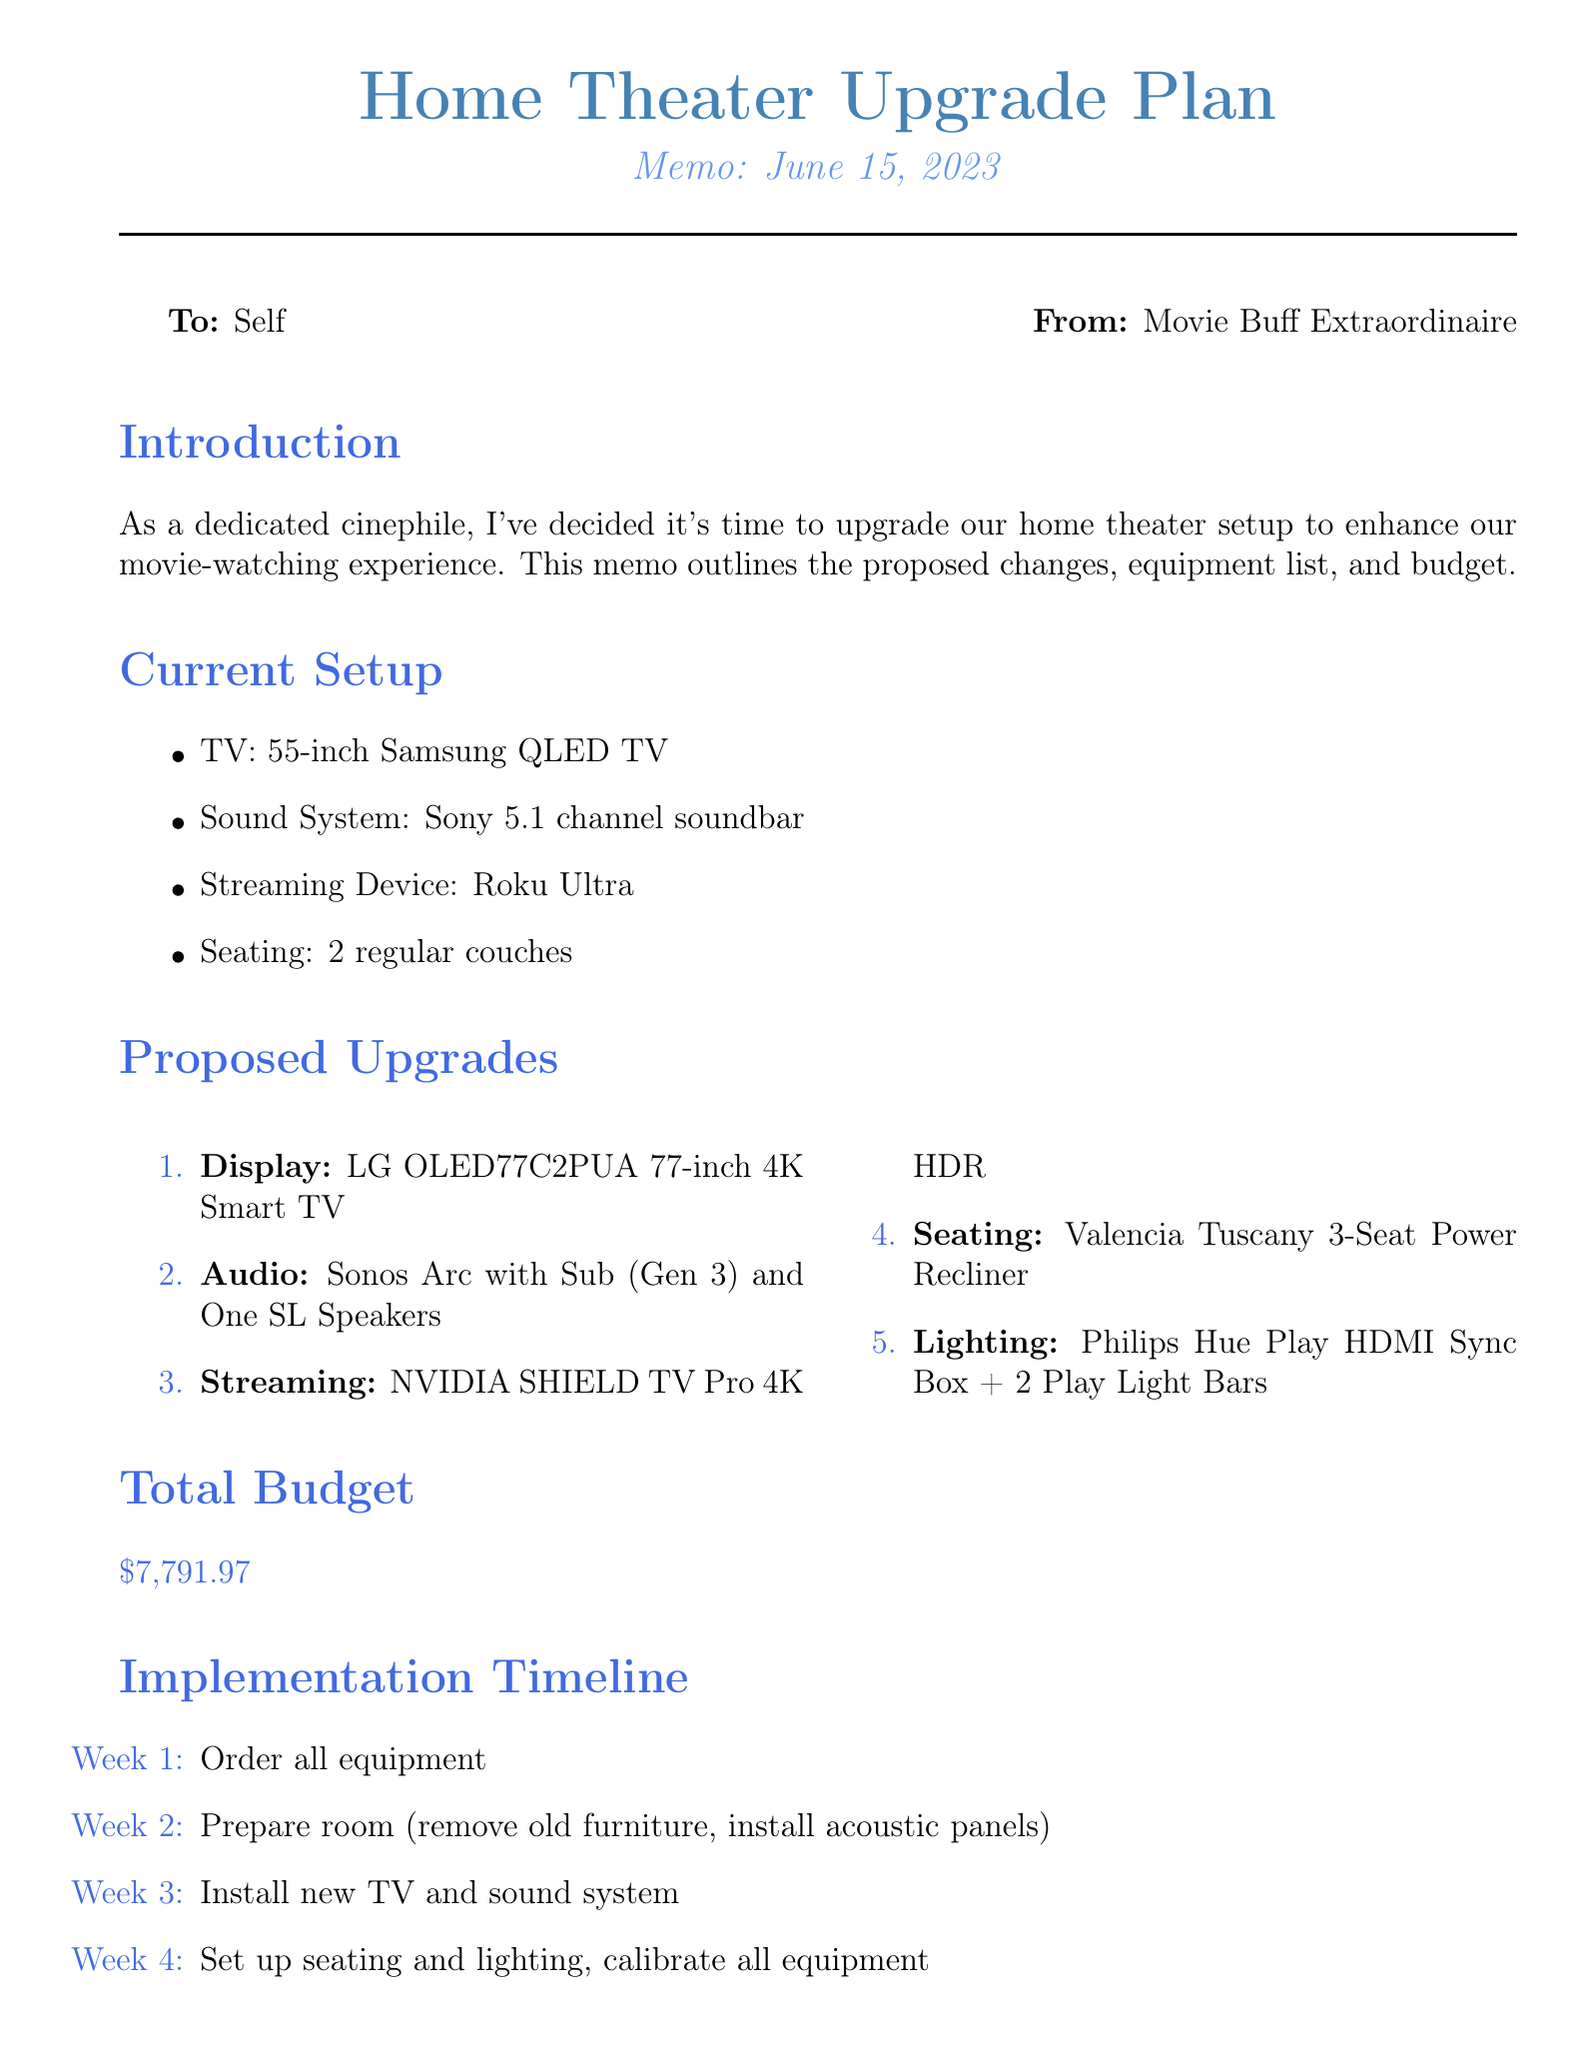What is the date of the memo? The memo was dated June 15, 2023.
Answer: June 15, 2023 Who is the memo addressed to? The memo is directed to "Self," indicating it is not for external distribution.
Answer: Self What is the estimated cost of the LG OLED77C2PUA TV? The estimated cost for the proposed LG OLED TV is mentioned in the upgrades section.
Answer: 2796.99 How many weeks are allocated for the implementation timeline? The implementation timeline outlines four distinct weeks for setup and installation.
Answer: 4 What is included in the audio upgrade? The audio upgrade lists the specific equipment being upgraded for sound quality.
Answer: Sonos Arc with Sub and One SL Speakers What is the total budget for the home theater upgrade? The total budget is calculated by summing all proposed costs associated with the upgrades.
Answer: 7791.97 Which seating upgrade is proposed? The seating upgrade details the specific model and features chosen for improved comfort.
Answer: Valencia Tuscany 3-Seat Power Recliner Home Theater Seating What additional consideration is mentioned regarding room acoustics? The memo suggests improving audio quality through various enhancements in the home theater.
Answer: Sound-absorbing panels What reason is given for upgrading to the NVIDIA SHIELD TV Pro? The reasoning provides insight into the functionality and benefits of the chosen streaming device.
Answer: AI upscaling for non-4K content 